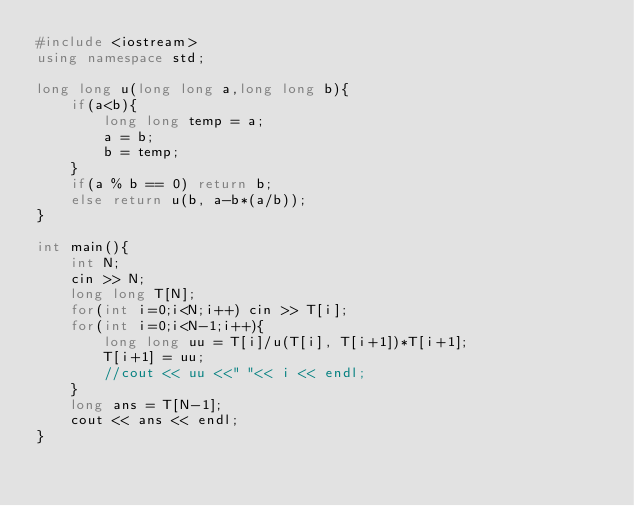<code> <loc_0><loc_0><loc_500><loc_500><_C++_>#include <iostream>
using namespace std;

long long u(long long a,long long b){
    if(a<b){
        long long temp = a;
        a = b;
        b = temp;
    }
    if(a % b == 0) return b;
    else return u(b, a-b*(a/b));
}

int main(){
    int N;
    cin >> N;
    long long T[N];
    for(int i=0;i<N;i++) cin >> T[i];
    for(int i=0;i<N-1;i++){
        long long uu = T[i]/u(T[i], T[i+1])*T[i+1];
        T[i+1] = uu;
        //cout << uu <<" "<< i << endl;
    }
    long ans = T[N-1];
    cout << ans << endl;
}</code> 